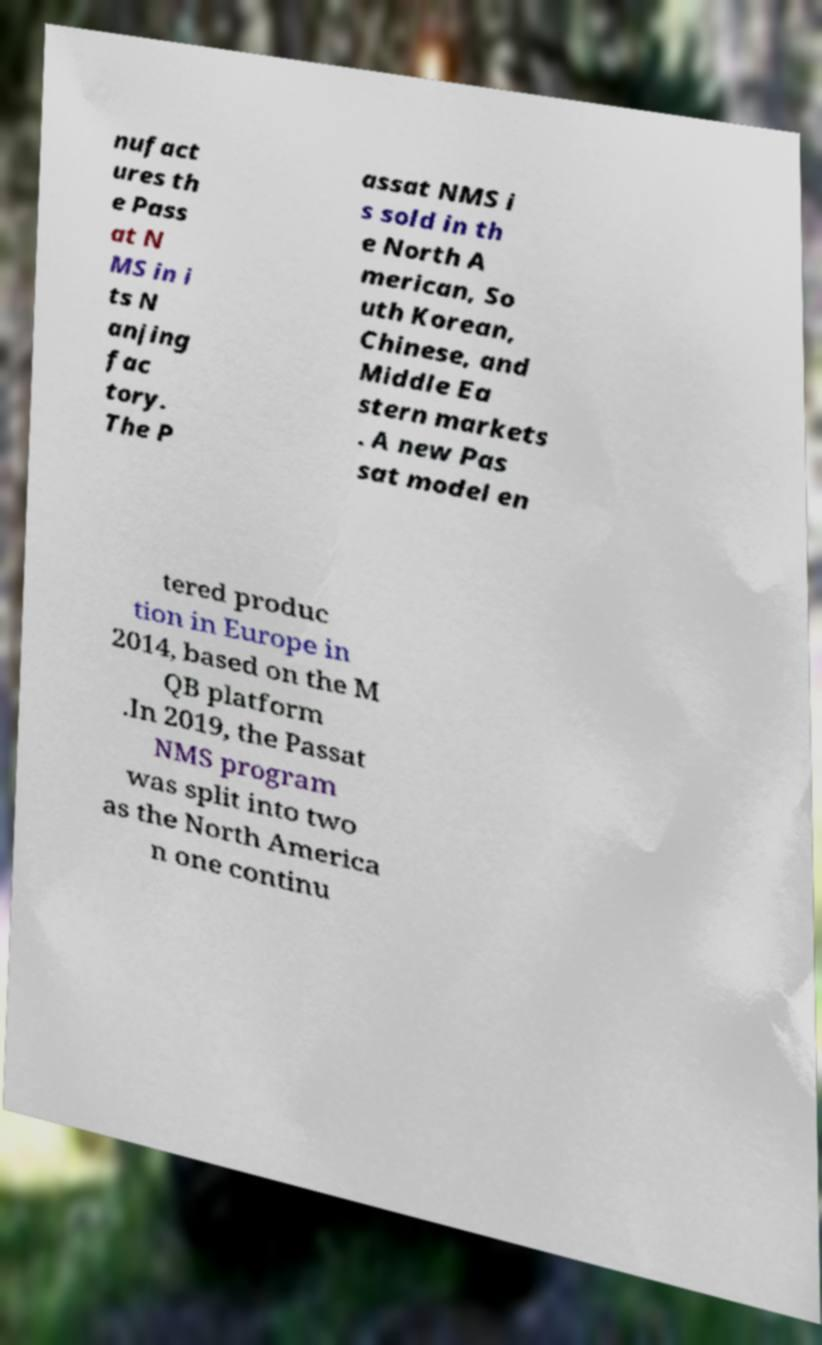Could you extract and type out the text from this image? nufact ures th e Pass at N MS in i ts N anjing fac tory. The P assat NMS i s sold in th e North A merican, So uth Korean, Chinese, and Middle Ea stern markets . A new Pas sat model en tered produc tion in Europe in 2014, based on the M QB platform .In 2019, the Passat NMS program was split into two as the North America n one continu 